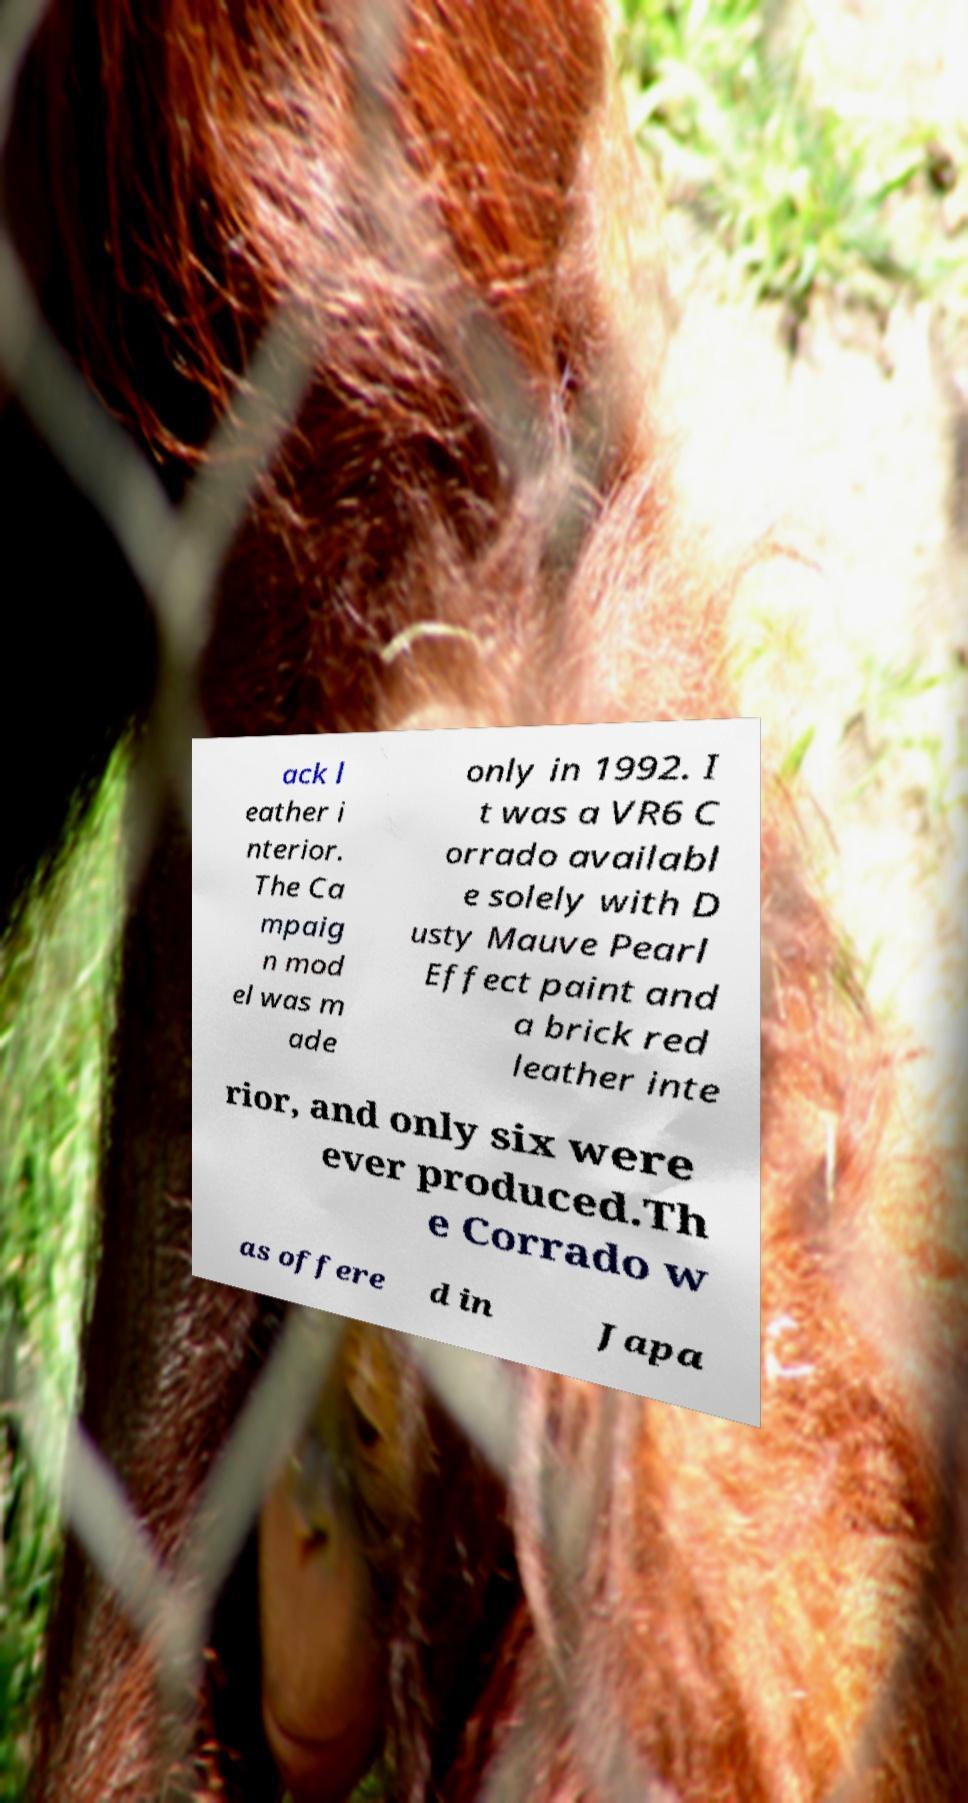Could you extract and type out the text from this image? ack l eather i nterior. The Ca mpaig n mod el was m ade only in 1992. I t was a VR6 C orrado availabl e solely with D usty Mauve Pearl Effect paint and a brick red leather inte rior, and only six were ever produced.Th e Corrado w as offere d in Japa 